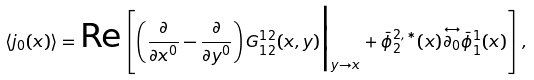<formula> <loc_0><loc_0><loc_500><loc_500>\langle j _ { 0 } ( x ) \rangle = \text {Re} \left [ \left ( \frac { \partial } { \partial x ^ { 0 } } - \frac { \partial } { \partial y ^ { 0 } } \right ) G _ { 1 2 } ^ { 1 2 } ( x , y ) \Big | _ { y \rightarrow x } + \bar { \phi } ^ { 2 , \ast } _ { 2 } ( x ) \overset { \leftrightarrow } { \partial _ { 0 } } \bar { \phi } ^ { 1 } _ { 1 } ( x ) \right ] ,</formula> 